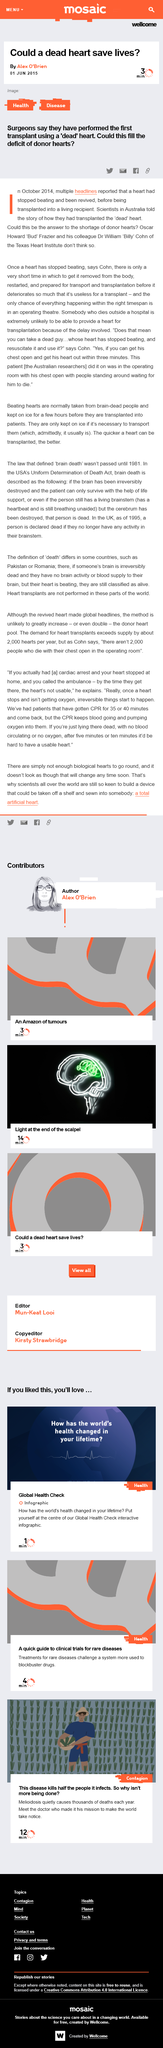Specify some key components in this picture. It was reported in October 2014 that a heart that had stopped beating was revived. On June 1st, 2015, the article "Could a dead heart save lives?" was published. 